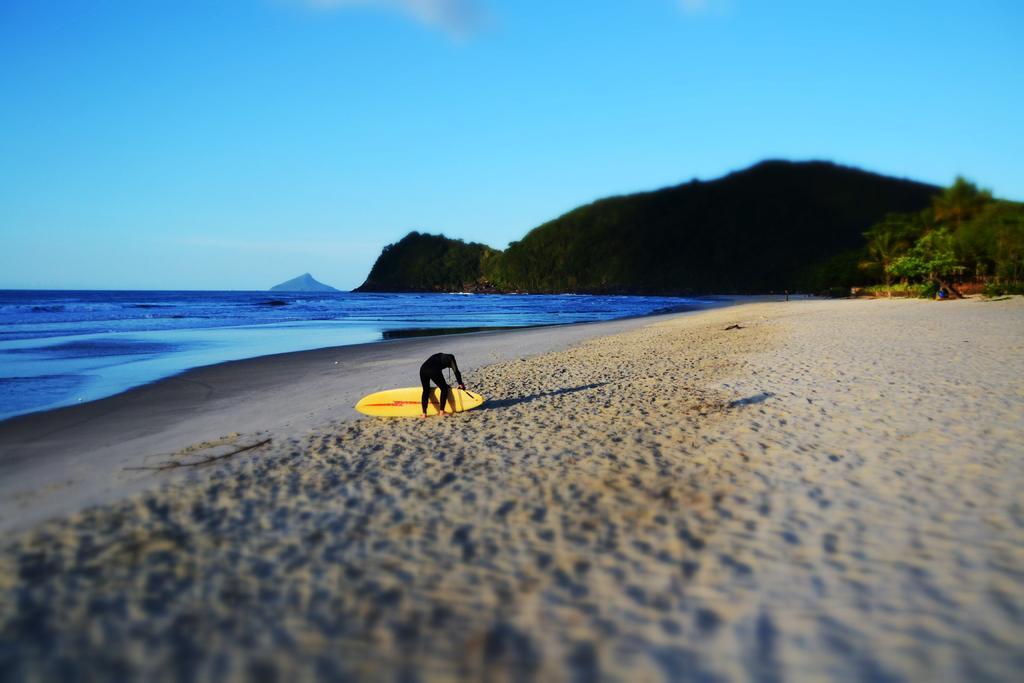Could you give a brief overview of what you see in this image? In this image there is a person holding the surfing boat. At the bottom of the image there is sand. In the background of the image there is water. There are trees, mountains. At the top of the image there is sky. 